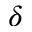Convert formula to latex. <formula><loc_0><loc_0><loc_500><loc_500>\delta</formula> 